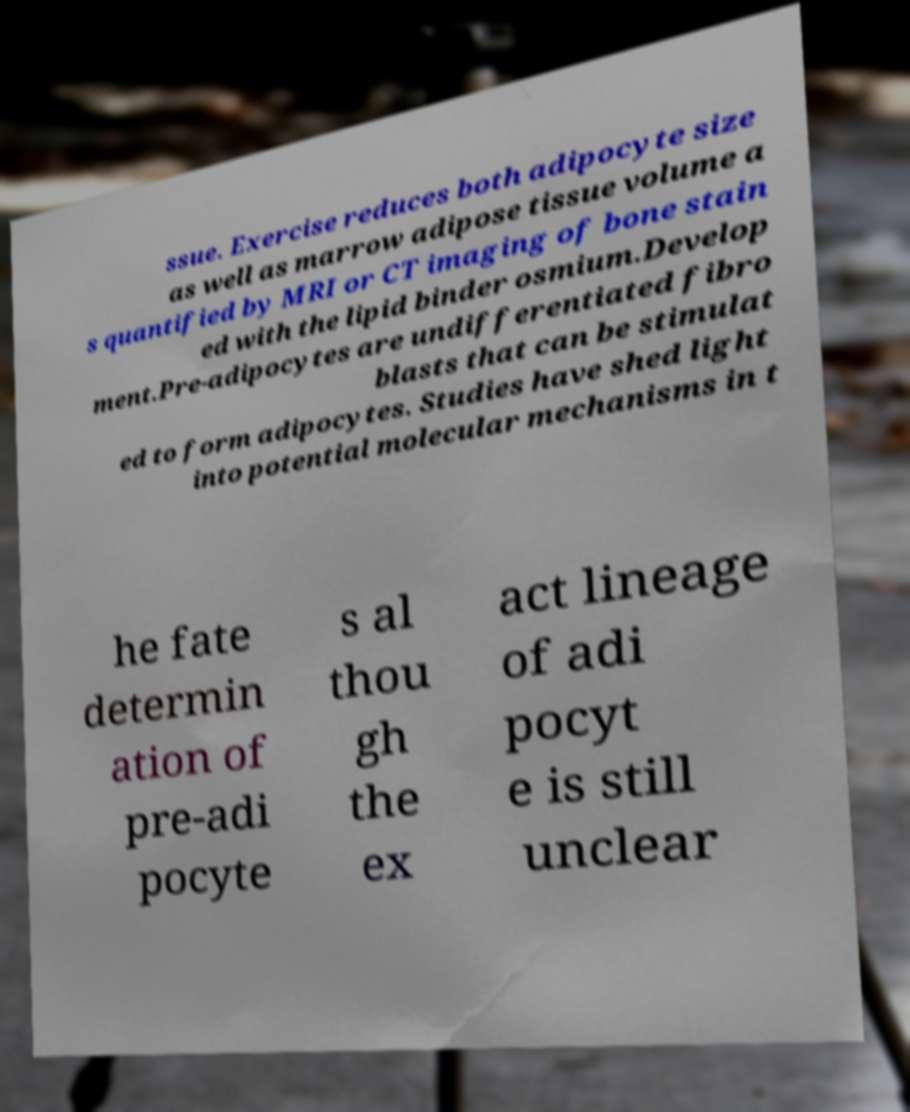Can you read and provide the text displayed in the image?This photo seems to have some interesting text. Can you extract and type it out for me? ssue. Exercise reduces both adipocyte size as well as marrow adipose tissue volume a s quantified by MRI or CT imaging of bone stain ed with the lipid binder osmium.Develop ment.Pre-adipocytes are undifferentiated fibro blasts that can be stimulat ed to form adipocytes. Studies have shed light into potential molecular mechanisms in t he fate determin ation of pre-adi pocyte s al thou gh the ex act lineage of adi pocyt e is still unclear 